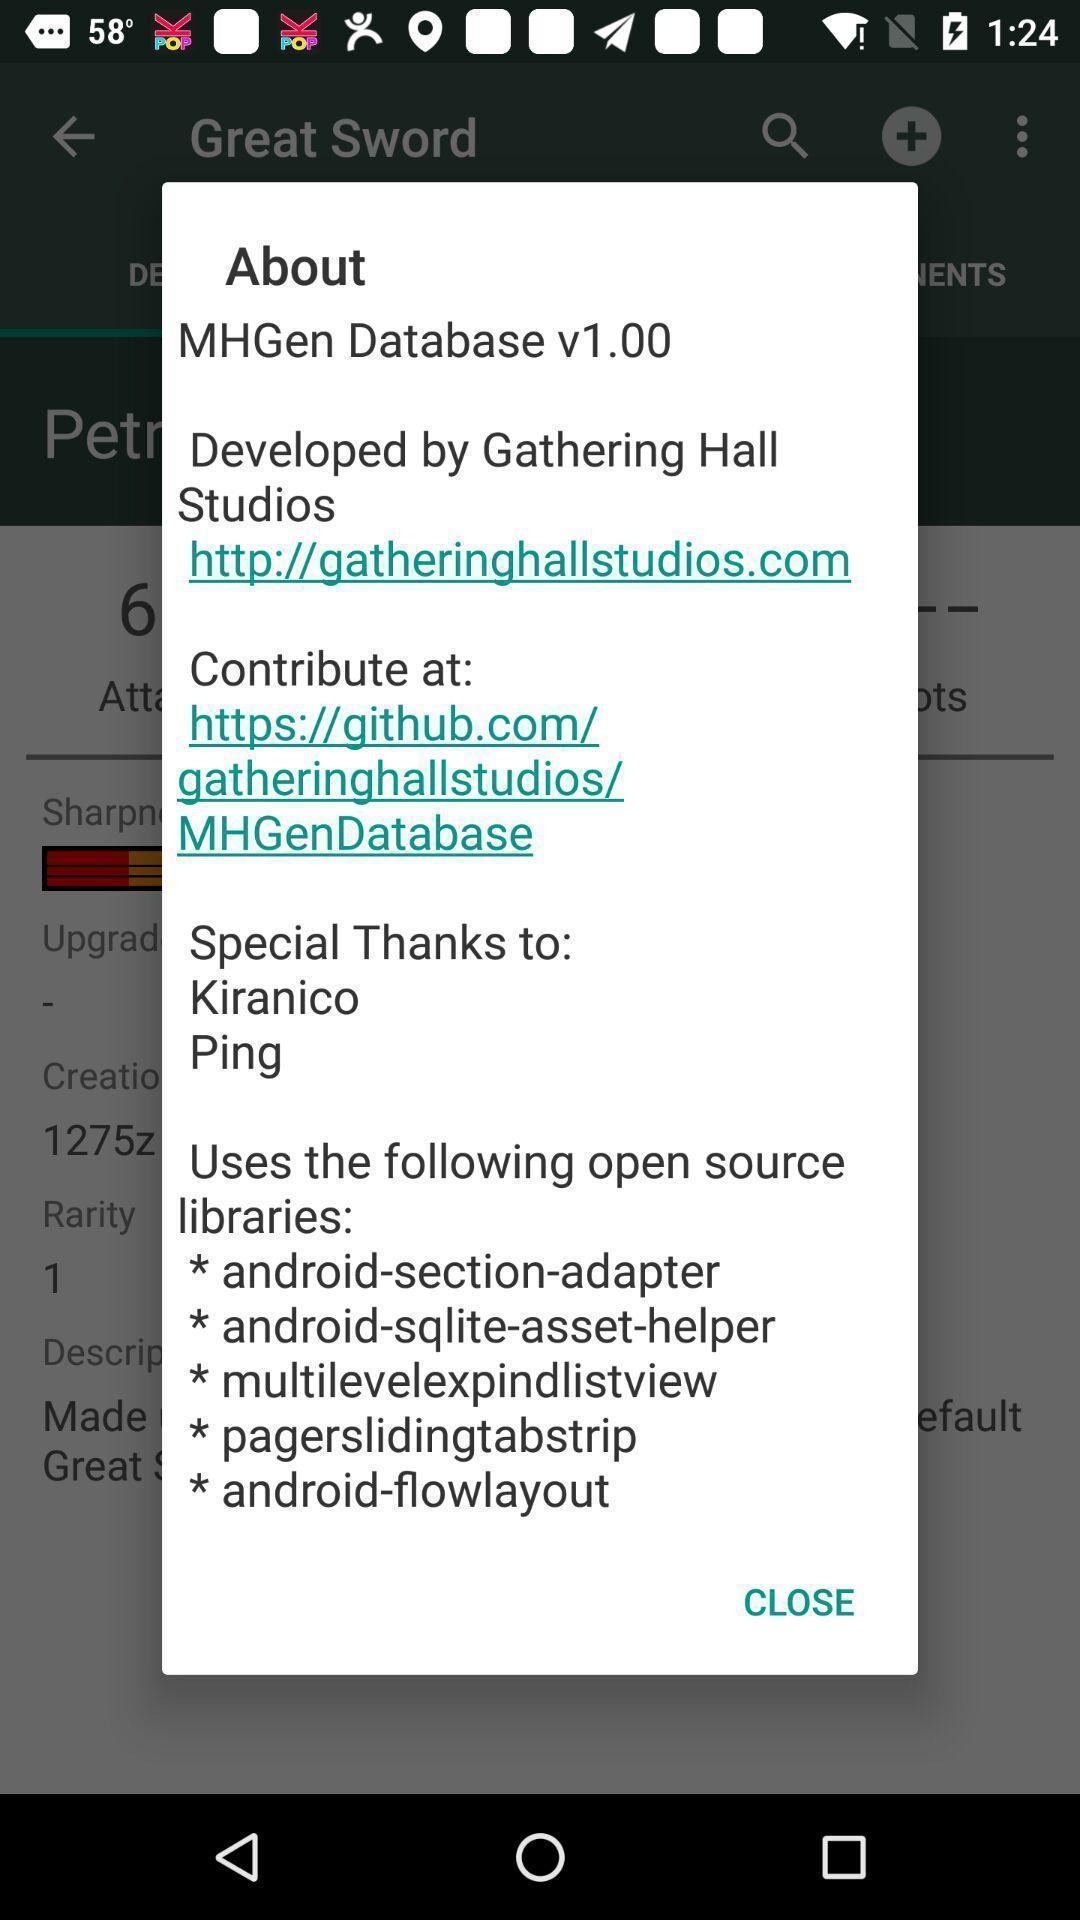Summarize the main components in this picture. Pop up window displaying the details about the app. 